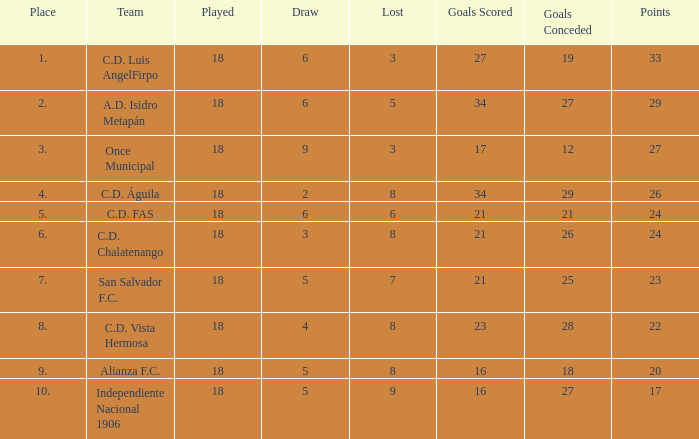What is the lowest amount of goals scored that has more than 19 goal conceded and played less than 18? None. 